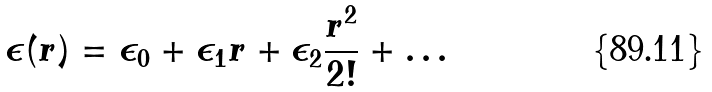Convert formula to latex. <formula><loc_0><loc_0><loc_500><loc_500>\epsilon ( r ) = \epsilon _ { 0 } + \epsilon _ { 1 } r + \epsilon _ { 2 } \frac { r ^ { 2 } } { 2 ! } + \dots</formula> 